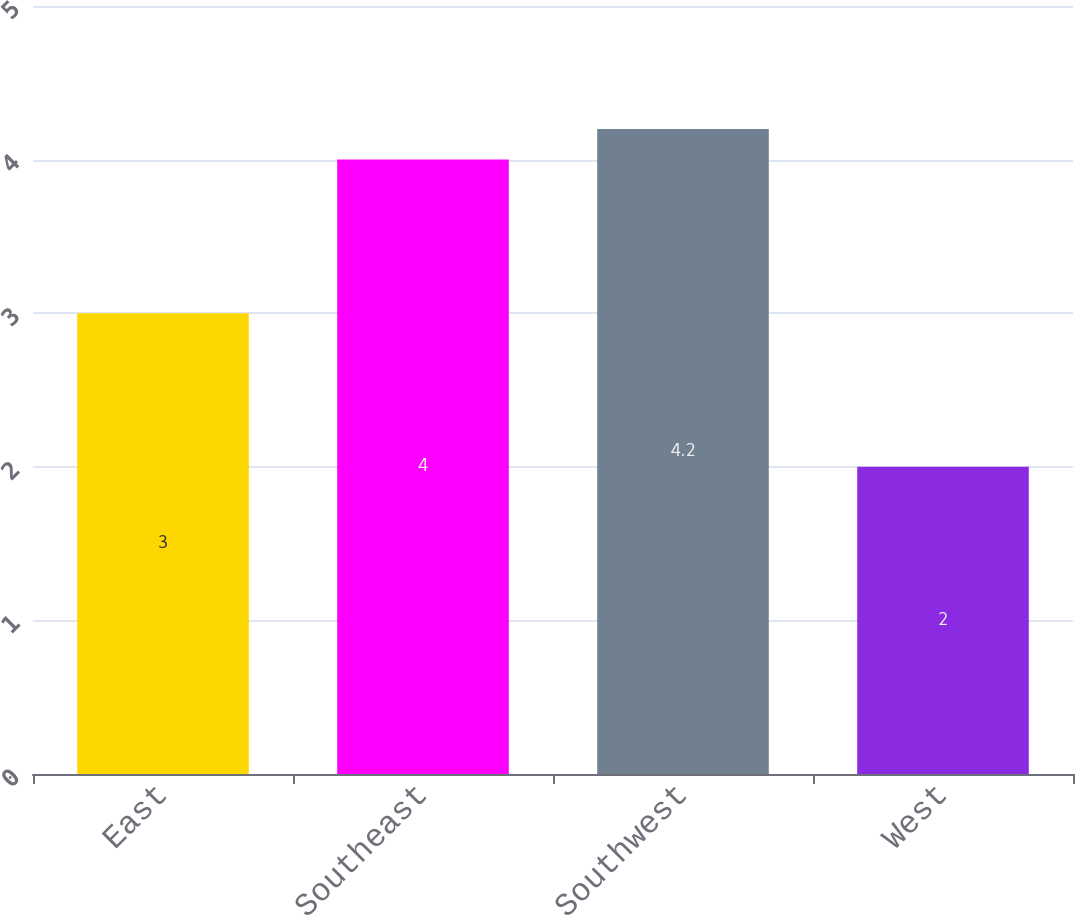Convert chart. <chart><loc_0><loc_0><loc_500><loc_500><bar_chart><fcel>East<fcel>Southeast<fcel>Southwest<fcel>West<nl><fcel>3<fcel>4<fcel>4.2<fcel>2<nl></chart> 